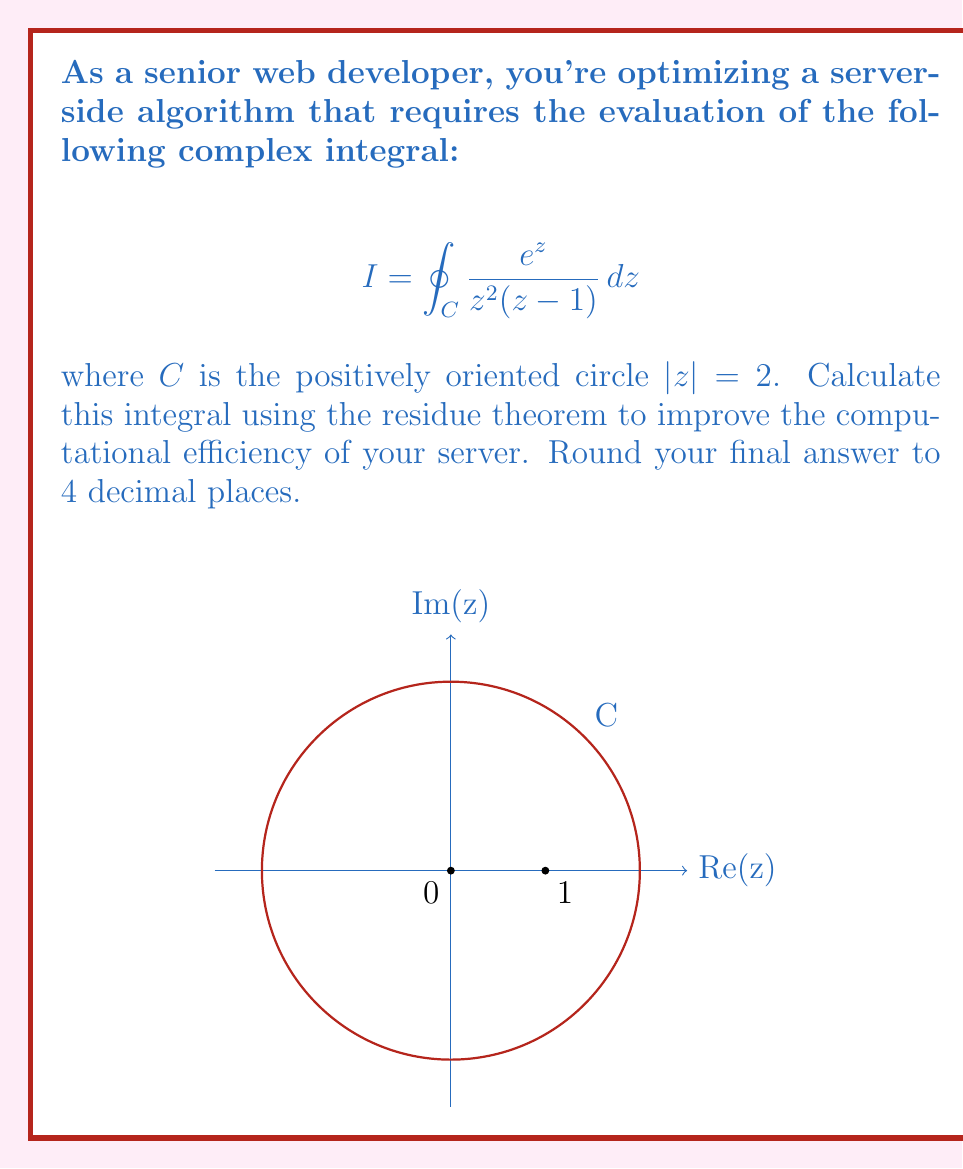Provide a solution to this math problem. To solve this integral using the residue theorem, we follow these steps:

1) The residue theorem states that for a function $f(z)$ that is analytic except for isolated singularities inside a simple closed contour $C$:

   $$\oint_C f(z) dz = 2\pi i \sum \text{Res}(f, a_k)$$

   where $a_k$ are the singularities inside $C$.

2) In our case, $f(z) = \frac{e^z}{z^2(z-1)}$. The singularities are at $z=0$ (order 2) and $z=1$ (order 1).

3) Both singularities are inside the contour $|z| = 2$, so we need to calculate residues at both points.

4) For $z=0$ (order 2 pole), we use the formula:

   $$\text{Res}(f,0) = \lim_{z \to 0} \frac{d}{dz} \left[z^2 \cdot \frac{e^z}{z^2(z-1)}\right] = \lim_{z \to 0} \frac{d}{dz} \left[\frac{e^z}{z-1}\right]$$

   $$= \lim_{z \to 0} \frac{e^z(z-1) - e^z(-1)}{(z-1)^2} = \lim_{z \to 0} \frac{e^z z}{(z-1)^2} = -1$$

5) For $z=1$ (simple pole), we use the formula:

   $$\text{Res}(f,1) = \lim_{z \to 1} (z-1) \cdot \frac{e^z}{z^2(z-1)} = \lim_{z \to 1} \frac{e^z}{z^2} = \frac{e}{1} = e$$

6) Applying the residue theorem:

   $$I = 2\pi i (\text{Res}(f,0) + \text{Res}(f,1)) = 2\pi i (-1 + e)$$

7) Evaluating and rounding to 4 decimal places:

   $$I = 2\pi i (e-1) \approx 10.9956 i$$
Answer: $10.9956i$ 